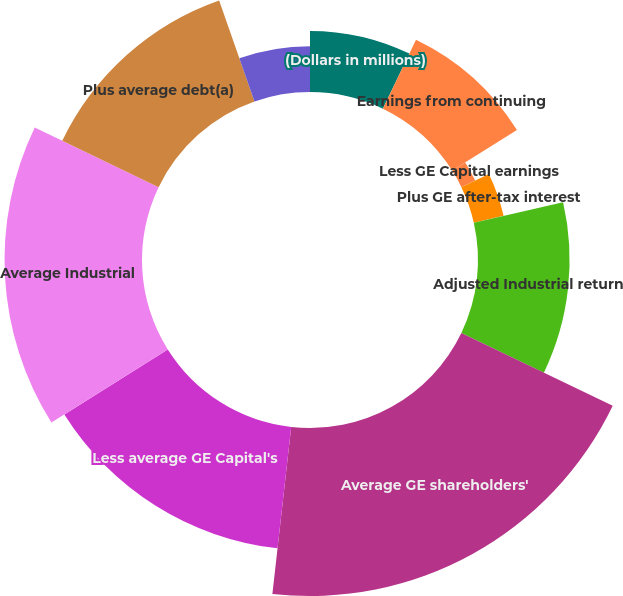<chart> <loc_0><loc_0><loc_500><loc_500><pie_chart><fcel>(Dollars in millions)<fcel>Earnings from continuing<fcel>Less GE Capital earnings<fcel>Plus GE after-tax interest<fcel>Adjusted Industrial return<fcel>Average GE shareholders'<fcel>Less average GE Capital's<fcel>Average Industrial<fcel>Plus average debt(a)<fcel>Plus other net(b)<nl><fcel>7.14%<fcel>8.93%<fcel>1.79%<fcel>3.57%<fcel>10.71%<fcel>19.64%<fcel>14.28%<fcel>16.07%<fcel>12.5%<fcel>5.36%<nl></chart> 